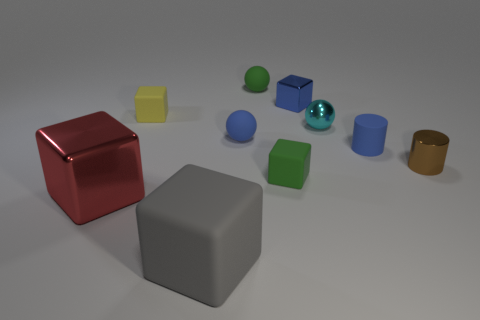Is the number of small green spheres in front of the tiny green ball greater than the number of large red metal things?
Ensure brevity in your answer.  No. Are there any tiny blue blocks?
Provide a short and direct response. Yes. What color is the big thing left of the large gray block?
Offer a very short reply. Red. There is another object that is the same size as the red thing; what material is it?
Your response must be concise. Rubber. What number of other things are made of the same material as the red object?
Offer a terse response. 3. What color is the shiny object that is both in front of the small cyan shiny object and to the left of the blue rubber cylinder?
Your answer should be very brief. Red. What number of objects are small yellow matte things that are to the left of the blue matte cylinder or small cylinders?
Offer a terse response. 3. How many other things are there of the same color as the matte cylinder?
Give a very brief answer. 2. Is the number of small metallic things that are left of the big gray matte object the same as the number of blue shiny blocks?
Give a very brief answer. No. There is a small rubber cube that is on the right side of the cube in front of the red shiny block; how many shiny blocks are on the left side of it?
Your answer should be compact. 1. 